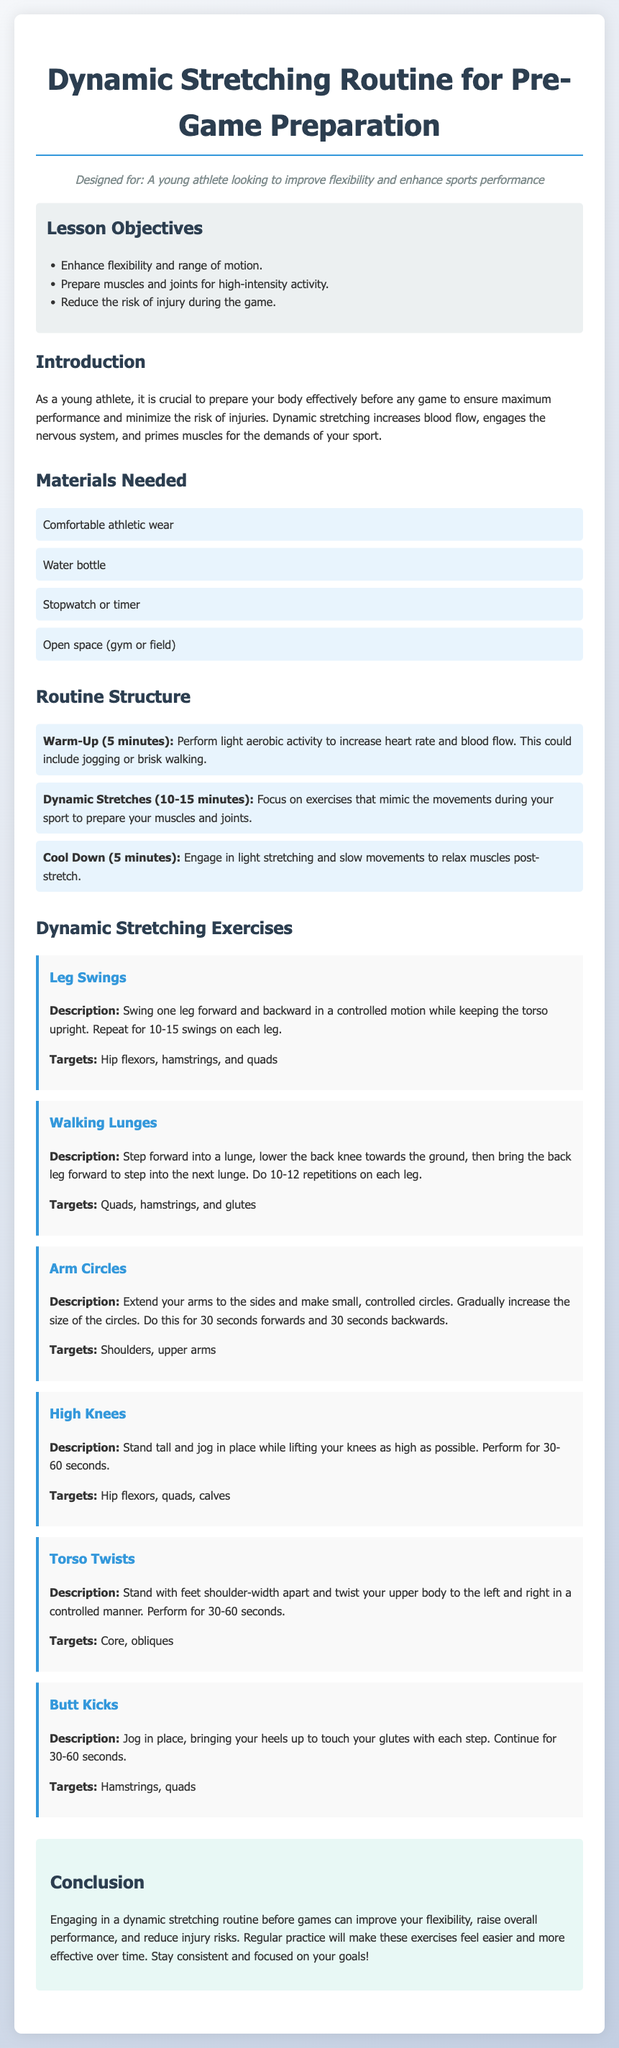What are the lesson objectives? The lesson objectives are listed in a section titled "Lesson Objectives" and include enhancing flexibility, preparing muscles, and reducing injury risk.
Answer: Enhance flexibility and range of motion, Prepare muscles and joints for high-intensity activity, Reduce the risk of injury during the game How long should the warm-up last? The warm-up is specified to last in the "Routine Structure" section, directly indicating the duration.
Answer: 5 minutes Which exercise targets the hip flexors, hamstrings, and quads? This information is found in the "Dynamic Stretching Exercises" section, describing the targets of specific exercises.
Answer: Leg Swings What is the main purpose of dynamic stretching as stated in the introduction? The introduction explains the purpose of dynamic stretching and its benefits for athletes.
Answer: Prepare your body effectively before any game How many repetitions should be performed for walking lunges? The number of repetitions for the walking lunges is clearly mentioned in the exercise description.
Answer: 10-12 repetitions on each leg What exercise involves jogging in place while lifting knees? This refers to an exercise listed under "Dynamic Stretching Exercises," which describes how to perform it.
Answer: High Knees What materials are required for the routine? The required materials are outlined in the "Materials Needed" section, specifically listing them.
Answer: Comfortable athletic wear, Water bottle, Stopwatch or timer, Open space (gym or field) What follows after the Dynamic Stretches in the routine structure? The sequence outlined in the "Routine Structure" indicates what comes after the dynamic stretches.
Answer: Cool Down (5 minutes) 